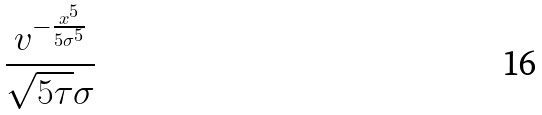<formula> <loc_0><loc_0><loc_500><loc_500>\frac { v ^ { - \frac { x ^ { 5 } } { 5 \sigma ^ { 5 } } } } { \sqrt { 5 \tau } \sigma }</formula> 